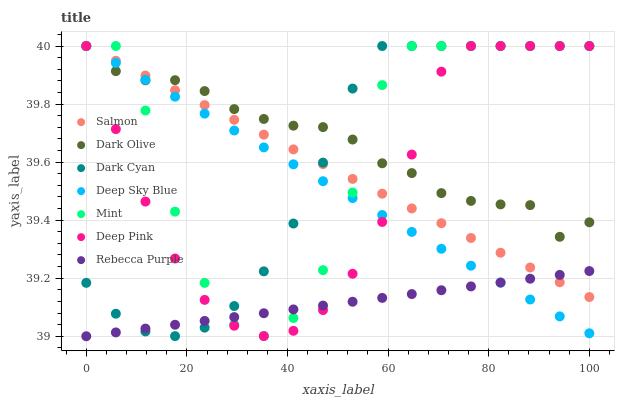Does Rebecca Purple have the minimum area under the curve?
Answer yes or no. Yes. Does Dark Olive have the maximum area under the curve?
Answer yes or no. Yes. Does Salmon have the minimum area under the curve?
Answer yes or no. No. Does Salmon have the maximum area under the curve?
Answer yes or no. No. Is Salmon the smoothest?
Answer yes or no. Yes. Is Mint the roughest?
Answer yes or no. Yes. Is Dark Olive the smoothest?
Answer yes or no. No. Is Dark Olive the roughest?
Answer yes or no. No. Does Rebecca Purple have the lowest value?
Answer yes or no. Yes. Does Salmon have the lowest value?
Answer yes or no. No. Does Mint have the highest value?
Answer yes or no. Yes. Does Rebecca Purple have the highest value?
Answer yes or no. No. Is Rebecca Purple less than Dark Olive?
Answer yes or no. Yes. Is Dark Olive greater than Rebecca Purple?
Answer yes or no. Yes. Does Salmon intersect Deep Pink?
Answer yes or no. Yes. Is Salmon less than Deep Pink?
Answer yes or no. No. Is Salmon greater than Deep Pink?
Answer yes or no. No. Does Rebecca Purple intersect Dark Olive?
Answer yes or no. No. 